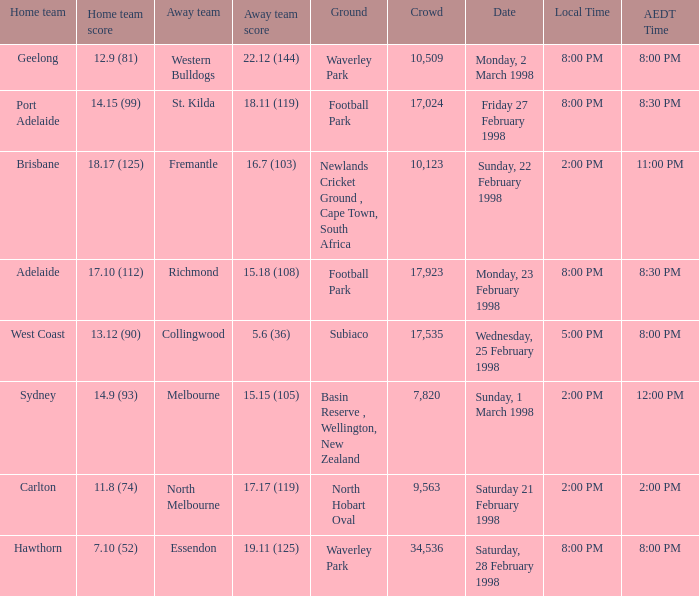Which Home team is on Wednesday, 25 february 1998? West Coast. 